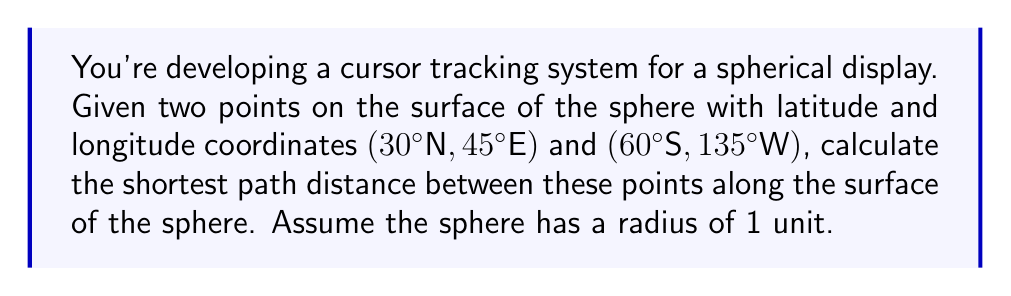Can you solve this math problem? To solve this problem, we'll use the great circle distance formula, which gives the shortest path between two points on a sphere's surface. Here's the step-by-step solution:

1) Convert the coordinates to radians:
   $\phi_1 = 30° \cdot \frac{\pi}{180} = \frac{\pi}{6}$
   $\lambda_1 = 45° \cdot \frac{\pi}{180} = \frac{\pi}{4}$
   $\phi_2 = -60° \cdot \frac{\pi}{180} = -\frac{\pi}{3}$
   $\lambda_2 = -135° \cdot \frac{\pi}{180} = -\frac{3\pi}{4}$

2) Use the Haversine formula to calculate the central angle $\Delta\sigma$:

   $$\Delta\sigma = 2 \arcsin\left(\sqrt{\sin^2\left(\frac{\Delta\phi}{2}\right) + \cos\phi_1 \cos\phi_2 \sin^2\left(\frac{\Delta\lambda}{2}\right)}\right)$$

   Where $\Delta\phi = \phi_2 - \phi_1$ and $\Delta\lambda = \lambda_2 - \lambda_1$

3) Calculate $\Delta\phi$ and $\Delta\lambda$:
   $\Delta\phi = -\frac{\pi}{3} - \frac{\pi}{6} = -\frac{\pi}{2}$
   $\Delta\lambda = -\frac{3\pi}{4} - \frac{\pi}{4} = -\pi$

4) Substitute into the Haversine formula:

   $$\Delta\sigma = 2 \arcsin\left(\sqrt{\sin^2\left(-\frac{\pi}{4}\right) + \cos\frac{\pi}{6} \cos\left(-\frac{\pi}{3}\right) \sin^2\left(-\frac{\pi}{2}\right)}\right)$$

5) Evaluate:
   $$\Delta\sigma \approx 2.5579 \text{ radians}$$

6) Since the radius is 1 unit, the arc length (shortest path distance) is equal to the central angle in radians.

Therefore, the shortest path distance is approximately 2.5579 units.
Answer: 2.5579 units 